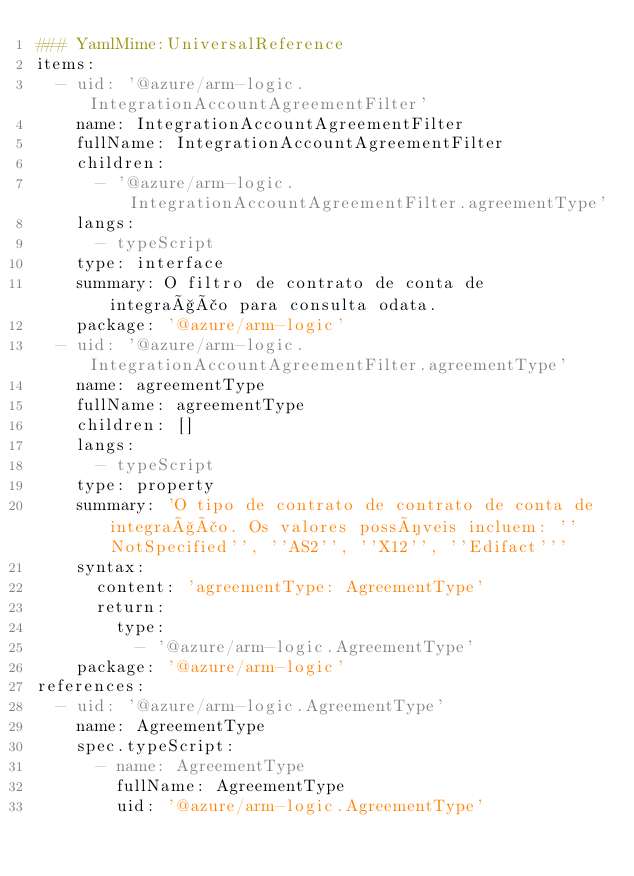<code> <loc_0><loc_0><loc_500><loc_500><_YAML_>### YamlMime:UniversalReference
items:
  - uid: '@azure/arm-logic.IntegrationAccountAgreementFilter'
    name: IntegrationAccountAgreementFilter
    fullName: IntegrationAccountAgreementFilter
    children:
      - '@azure/arm-logic.IntegrationAccountAgreementFilter.agreementType'
    langs:
      - typeScript
    type: interface
    summary: O filtro de contrato de conta de integração para consulta odata.
    package: '@azure/arm-logic'
  - uid: '@azure/arm-logic.IntegrationAccountAgreementFilter.agreementType'
    name: agreementType
    fullName: agreementType
    children: []
    langs:
      - typeScript
    type: property
    summary: 'O tipo de contrato de contrato de conta de integração. Os valores possíveis incluem: ''NotSpecified'', ''AS2'', ''X12'', ''Edifact'''
    syntax:
      content: 'agreementType: AgreementType'
      return:
        type:
          - '@azure/arm-logic.AgreementType'
    package: '@azure/arm-logic'
references:
  - uid: '@azure/arm-logic.AgreementType'
    name: AgreementType
    spec.typeScript:
      - name: AgreementType
        fullName: AgreementType
        uid: '@azure/arm-logic.AgreementType'</code> 